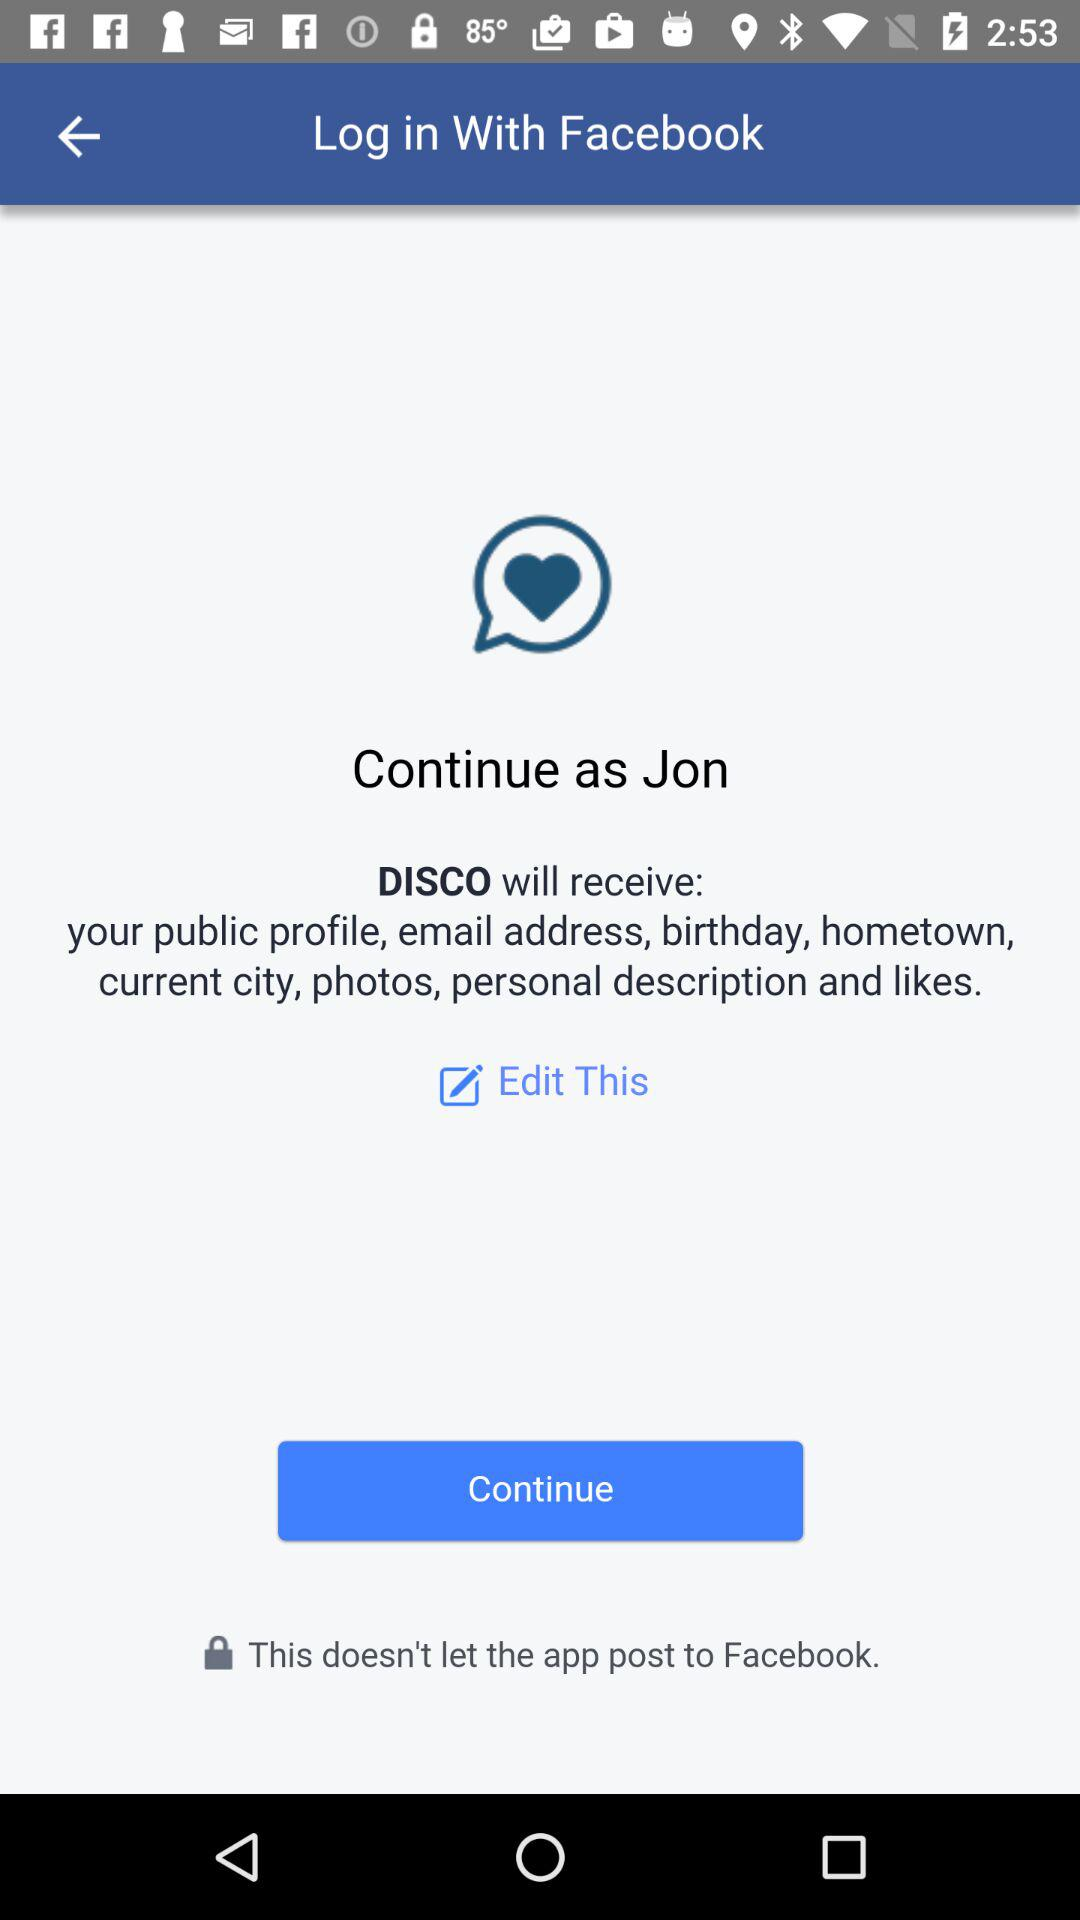What is the login name? The login name is Jon. 